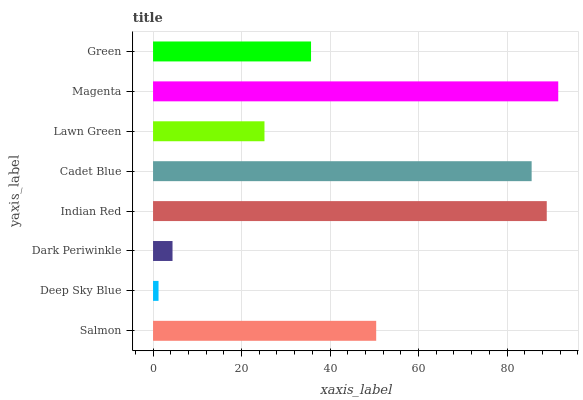Is Deep Sky Blue the minimum?
Answer yes or no. Yes. Is Magenta the maximum?
Answer yes or no. Yes. Is Dark Periwinkle the minimum?
Answer yes or no. No. Is Dark Periwinkle the maximum?
Answer yes or no. No. Is Dark Periwinkle greater than Deep Sky Blue?
Answer yes or no. Yes. Is Deep Sky Blue less than Dark Periwinkle?
Answer yes or no. Yes. Is Deep Sky Blue greater than Dark Periwinkle?
Answer yes or no. No. Is Dark Periwinkle less than Deep Sky Blue?
Answer yes or no. No. Is Salmon the high median?
Answer yes or no. Yes. Is Green the low median?
Answer yes or no. Yes. Is Green the high median?
Answer yes or no. No. Is Deep Sky Blue the low median?
Answer yes or no. No. 